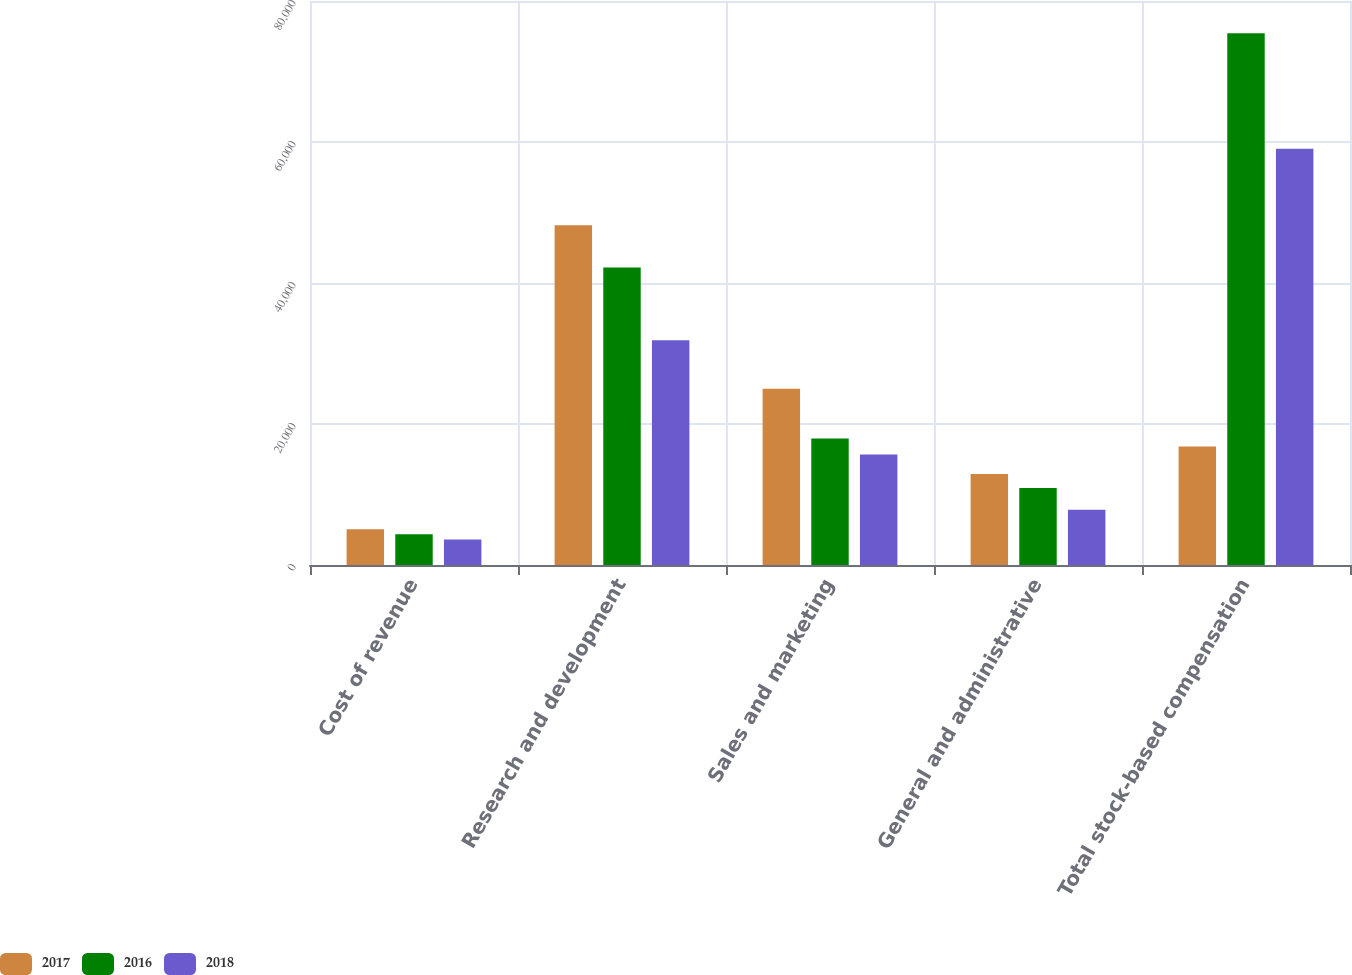<chart> <loc_0><loc_0><loc_500><loc_500><stacked_bar_chart><ecel><fcel>Cost of revenue<fcel>Research and development<fcel>Sales and marketing<fcel>General and administrative<fcel>Total stock-based compensation<nl><fcel>2017<fcel>5087<fcel>48205<fcel>24995<fcel>12915<fcel>16809.5<nl><fcel>2016<fcel>4353<fcel>42184<fcel>17953<fcel>10937<fcel>75427<nl><fcel>2018<fcel>3620<fcel>31892<fcel>15666<fcel>7854<fcel>59032<nl></chart> 